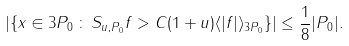Convert formula to latex. <formula><loc_0><loc_0><loc_500><loc_500>| \{ x \in 3 P _ { 0 } \, \colon \, S _ { u , P _ { 0 } } f > C ( 1 + u ) \langle | f | \rangle _ { 3 P _ { 0 } } \} | \leq \frac { 1 } { 8 } | P _ { 0 } | .</formula> 